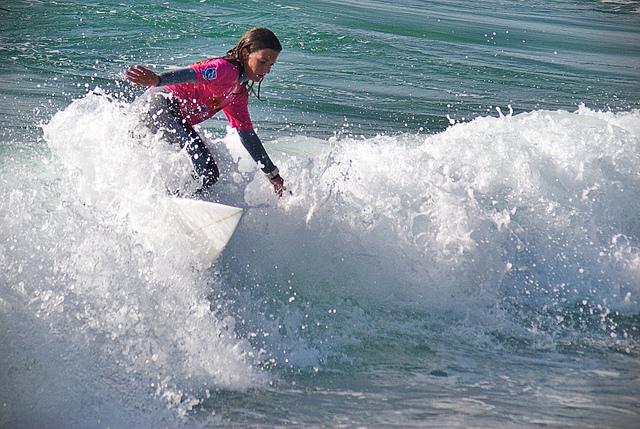Is it a sunny day?
Be succinct. Yes. Is that a pool she is surfing in?
Give a very brief answer. No. Is this girl over the age of 18?
Keep it brief. Yes. 